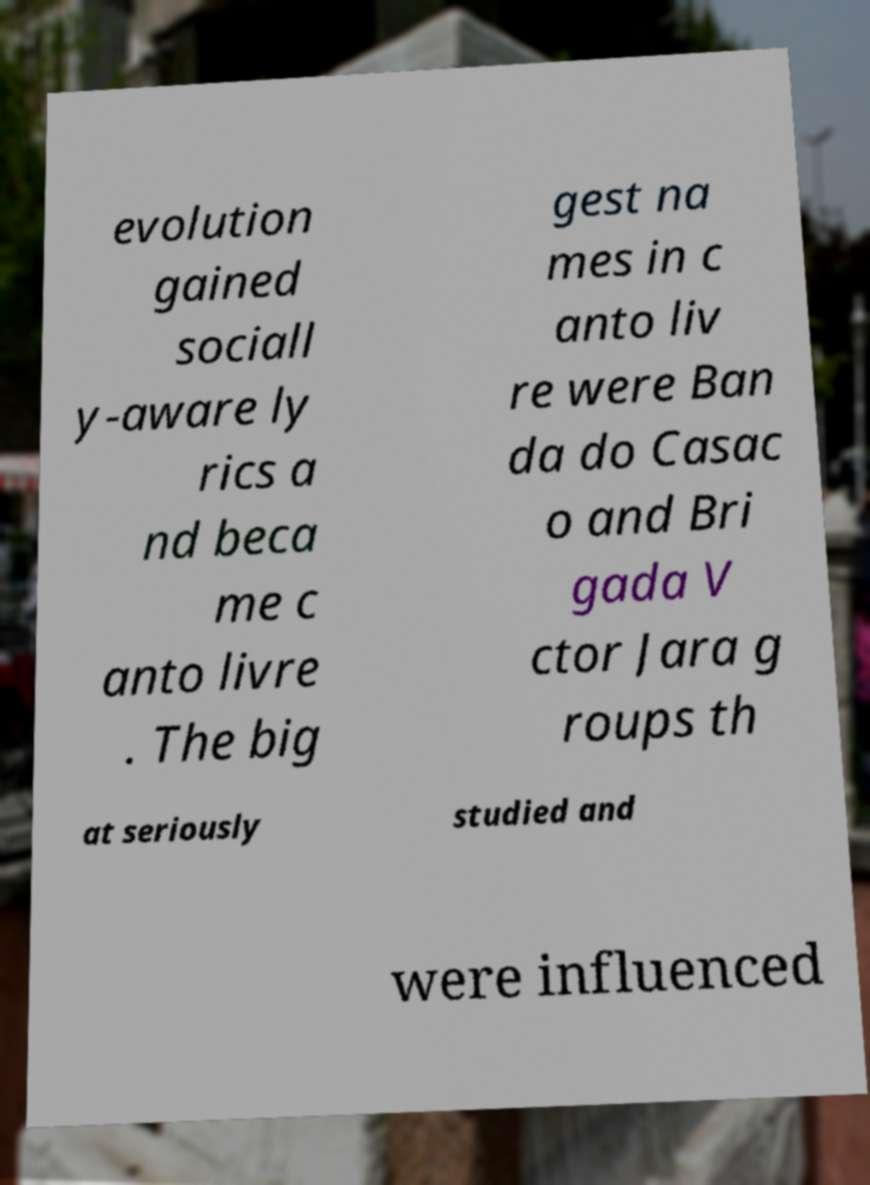Could you assist in decoding the text presented in this image and type it out clearly? evolution gained sociall y-aware ly rics a nd beca me c anto livre . The big gest na mes in c anto liv re were Ban da do Casac o and Bri gada V ctor Jara g roups th at seriously studied and were influenced 